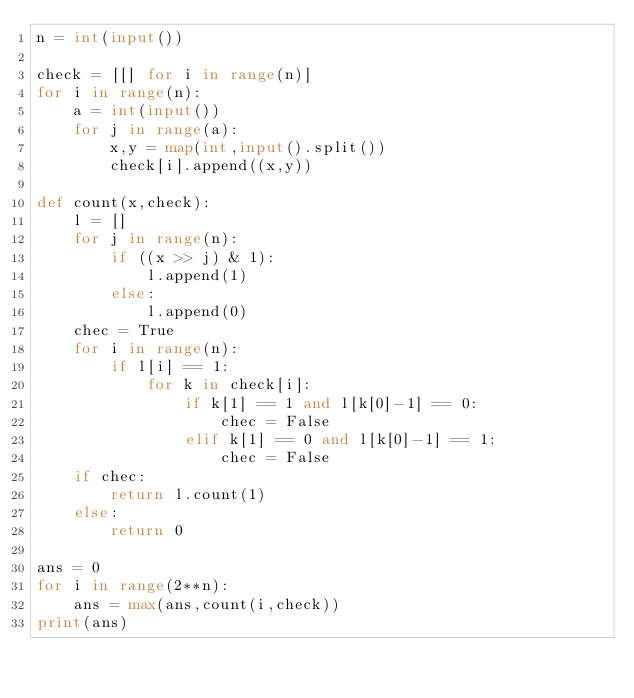<code> <loc_0><loc_0><loc_500><loc_500><_Python_>n = int(input())

check = [[] for i in range(n)]
for i in range(n):
    a = int(input())
    for j in range(a):
        x,y = map(int,input().split())
        check[i].append((x,y))

def count(x,check):
    l = []
    for j in range(n):
        if ((x >> j) & 1):
            l.append(1)
        else:
            l.append(0)
    chec = True
    for i in range(n):
        if l[i] == 1:
            for k in check[i]:
                if k[1] == 1 and l[k[0]-1] == 0:
                    chec = False
                elif k[1] == 0 and l[k[0]-1] == 1:
                    chec = False
    if chec:
        return l.count(1)
    else:
        return 0

ans = 0
for i in range(2**n):
    ans = max(ans,count(i,check))
print(ans)


</code> 